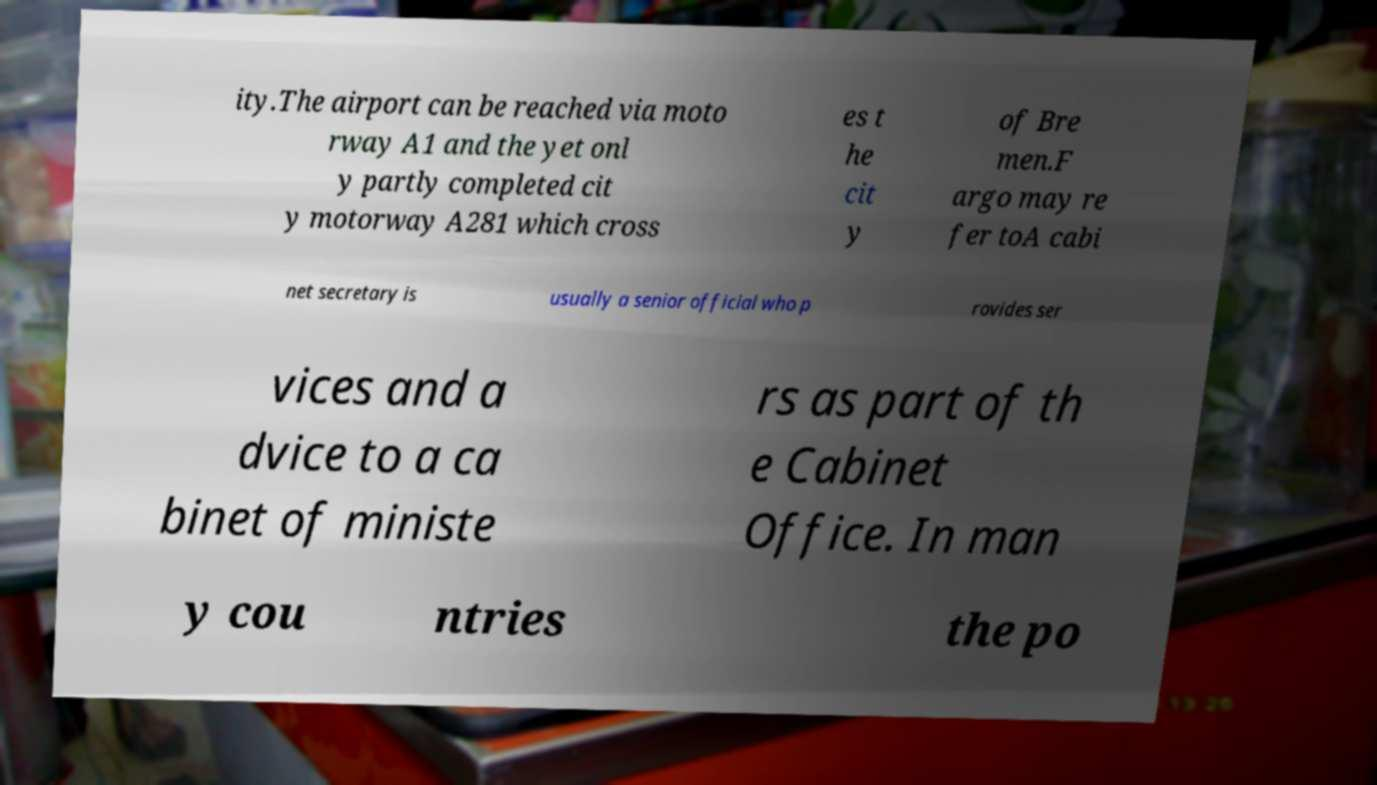Please read and relay the text visible in this image. What does it say? ity.The airport can be reached via moto rway A1 and the yet onl y partly completed cit y motorway A281 which cross es t he cit y of Bre men.F argo may re fer toA cabi net secretary is usually a senior official who p rovides ser vices and a dvice to a ca binet of ministe rs as part of th e Cabinet Office. In man y cou ntries the po 